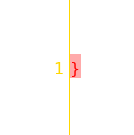<code> <loc_0><loc_0><loc_500><loc_500><_CSS_>}
</code> 